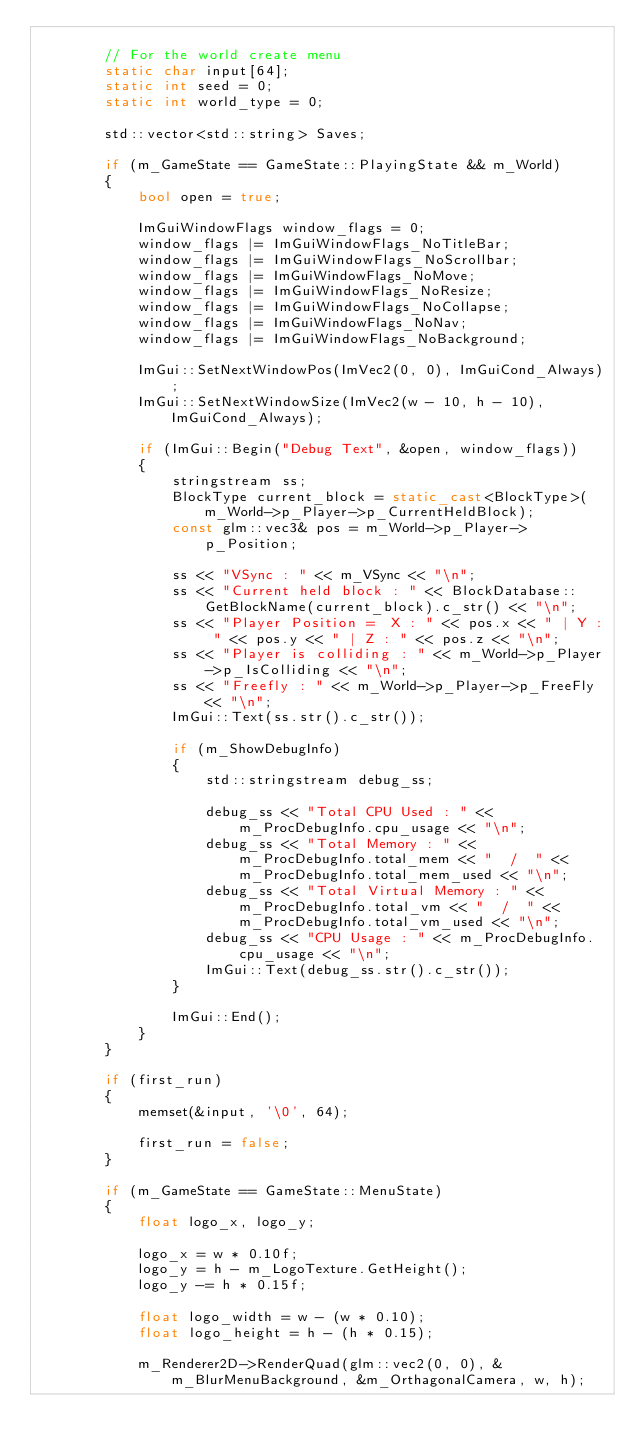Convert code to text. <code><loc_0><loc_0><loc_500><loc_500><_C++_>
		// For the world create menu
		static char input[64];
		static int seed = 0;
		static int world_type = 0;

		std::vector<std::string> Saves;

		if (m_GameState == GameState::PlayingState && m_World)
		{
			bool open = true;

			ImGuiWindowFlags window_flags = 0;
			window_flags |= ImGuiWindowFlags_NoTitleBar;
			window_flags |= ImGuiWindowFlags_NoScrollbar;
			window_flags |= ImGuiWindowFlags_NoMove;
			window_flags |= ImGuiWindowFlags_NoResize;
			window_flags |= ImGuiWindowFlags_NoCollapse;
			window_flags |= ImGuiWindowFlags_NoNav;
			window_flags |= ImGuiWindowFlags_NoBackground;

			ImGui::SetNextWindowPos(ImVec2(0, 0), ImGuiCond_Always);
			ImGui::SetNextWindowSize(ImVec2(w - 10, h - 10), ImGuiCond_Always);

			if (ImGui::Begin("Debug Text", &open, window_flags))
			{
				stringstream ss;
				BlockType current_block = static_cast<BlockType>(m_World->p_Player->p_CurrentHeldBlock);
				const glm::vec3& pos = m_World->p_Player->p_Position;

				ss << "VSync : " << m_VSync << "\n";
				ss << "Current held block : " << BlockDatabase::GetBlockName(current_block).c_str() << "\n";
				ss << "Player Position =  X : " << pos.x << " | Y : " << pos.y << " | Z : " << pos.z << "\n"; 
				ss << "Player is colliding : " << m_World->p_Player->p_IsColliding << "\n";
				ss << "Freefly : " << m_World->p_Player->p_FreeFly << "\n";
				ImGui::Text(ss.str().c_str());
				
				if (m_ShowDebugInfo)
				{
					std::stringstream debug_ss;

					debug_ss << "Total CPU Used : " << m_ProcDebugInfo.cpu_usage << "\n";
					debug_ss << "Total Memory : " << m_ProcDebugInfo.total_mem << "  /  " << m_ProcDebugInfo.total_mem_used << "\n";
					debug_ss << "Total Virtual Memory : " << m_ProcDebugInfo.total_vm << "  /  " << m_ProcDebugInfo.total_vm_used << "\n";
					debug_ss << "CPU Usage : " << m_ProcDebugInfo.cpu_usage << "\n";
					ImGui::Text(debug_ss.str().c_str());
				}

				ImGui::End();
			}
		}

		if (first_run)
		{
			memset(&input, '\0', 64);

			first_run = false;
		}
		
		if (m_GameState == GameState::MenuState)
		{
			float logo_x, logo_y;
			
			logo_x = w * 0.10f;
			logo_y = h - m_LogoTexture.GetHeight();
			logo_y -= h * 0.15f;

			float logo_width = w - (w * 0.10);
			float logo_height = h - (h * 0.15);

			m_Renderer2D->RenderQuad(glm::vec2(0, 0), &m_BlurMenuBackground, &m_OrthagonalCamera, w, h);</code> 